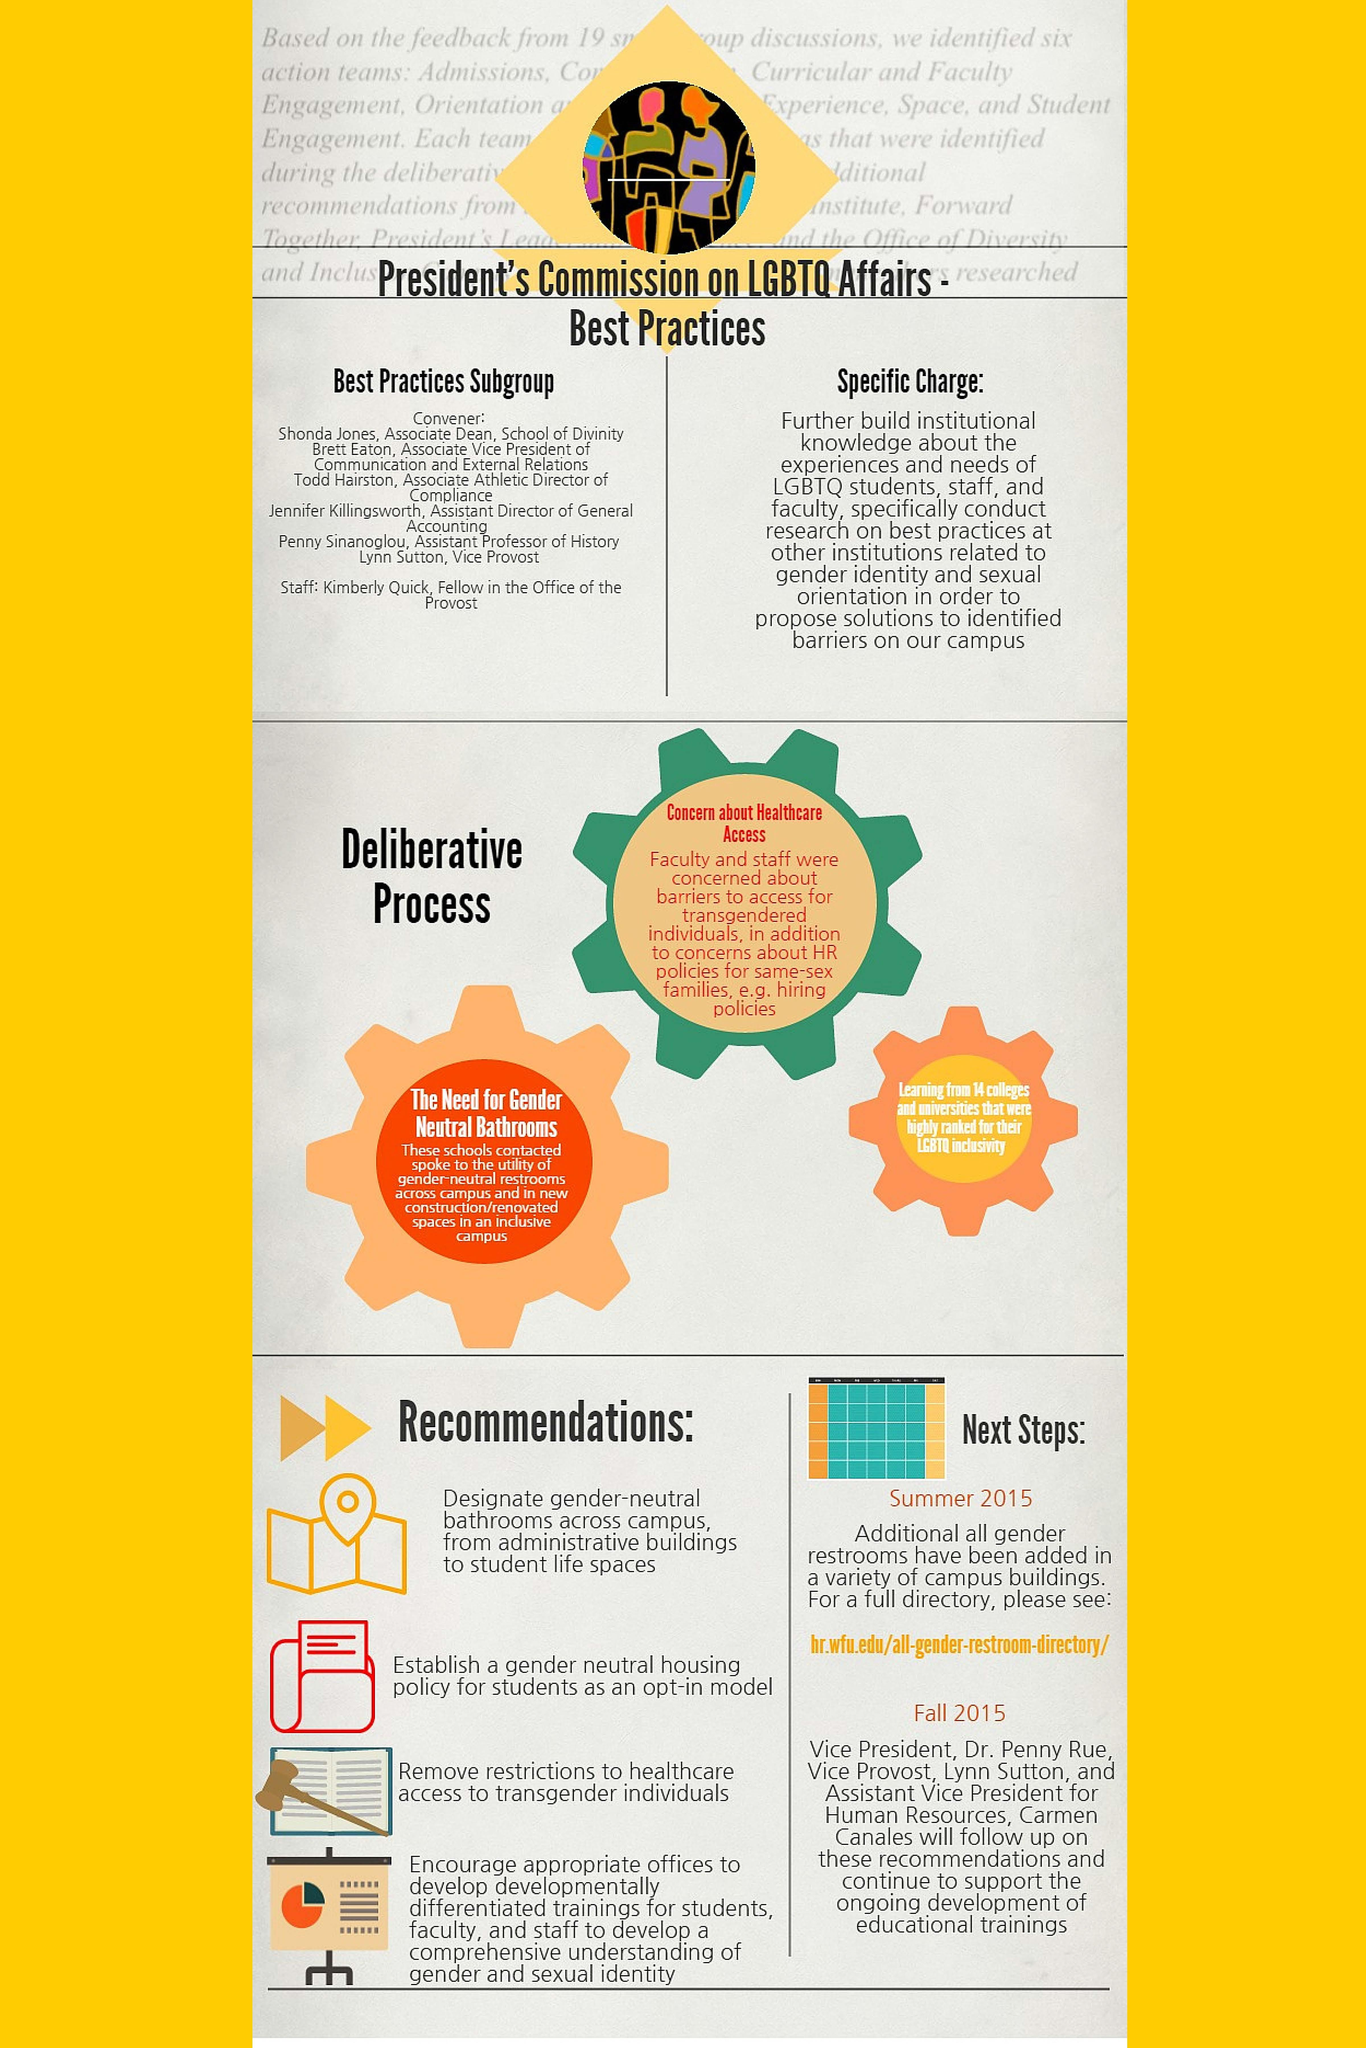List a handful of essential elements in this visual. Three deliberative processes have been identified. It is expected that follow-up on recommendations will be completed in the fall of 2015. In 2015, it was announced that additional all-gender restrooms would be added. I'm sorry, but I'm not sure what you are asking. Could you please provide more context or clarify your question? 